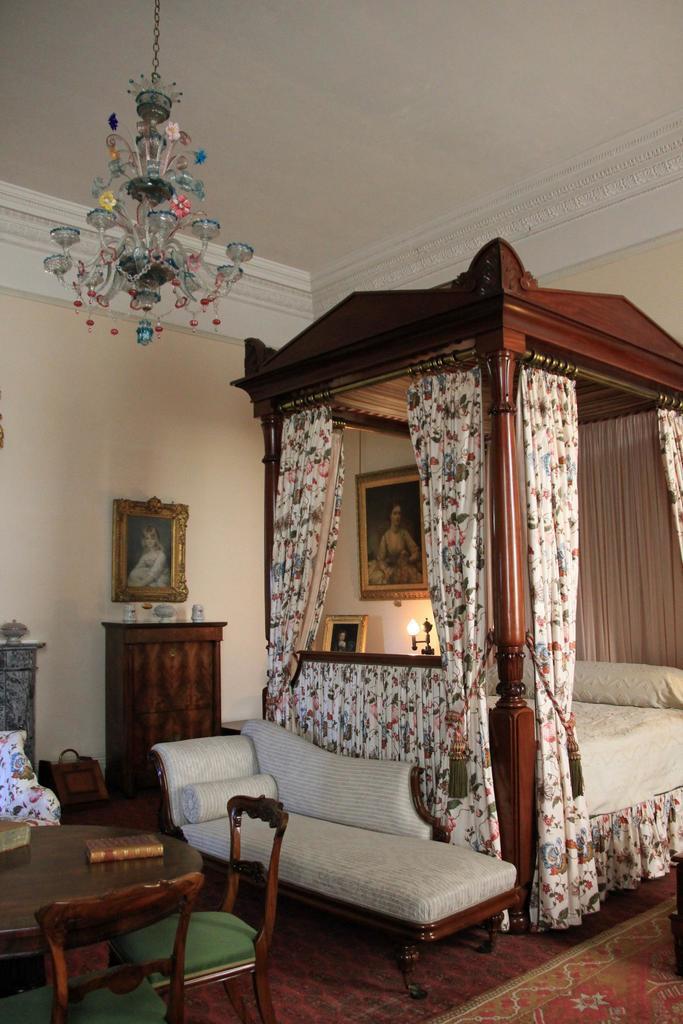Can you describe this image briefly? This image is clicked in a bedroom. To the right, there is a bed and couch beside it. To the left, there is a table along with chairs. In the background, there is a wall on which a frame is fixed. At the bottom there is a floor mat on the floor. 